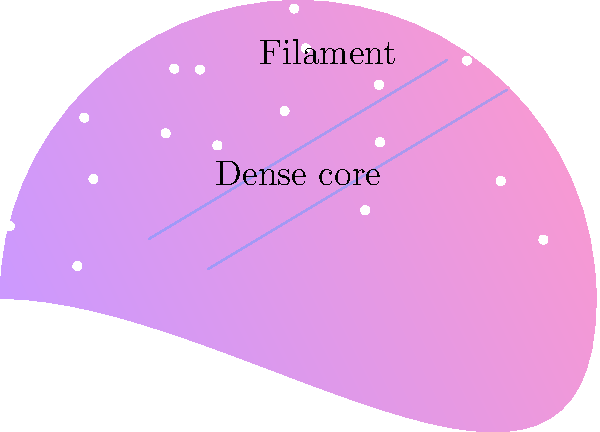In the context of nebula structure, what is the term for the elongated, thread-like features often observed in detailed images, as shown in the illustration? To answer this question, let's break down the structure of a nebula:

1. Nebulae are vast clouds of gas and dust in space.
2. They have complex structures due to various physical processes like gravity, radiation, and magnetic fields.
3. In the image, we can see a cloud-like formation with different colors representing varying densities and temperatures.
4. The central, denser region is labeled as the "Dense core," which is typically where star formation occurs.
5. The elongated, thread-like structures extending from the core are key features in many nebulae.
6. These structures are called "filaments" and are labeled in the image.
7. Filaments are important in nebula structure because:
   a) They channel gas and dust towards the dense core.
   b) They can fragment to form smaller cores that may become stars.
   c) They often show the influence of magnetic fields on the nebula's shape.
8. In Warhammer game design, understanding these structures can help in creating realistic and visually appealing cosmic landscapes for game settings.

The term for these elongated, thread-like features is "filaments."
Answer: Filaments 